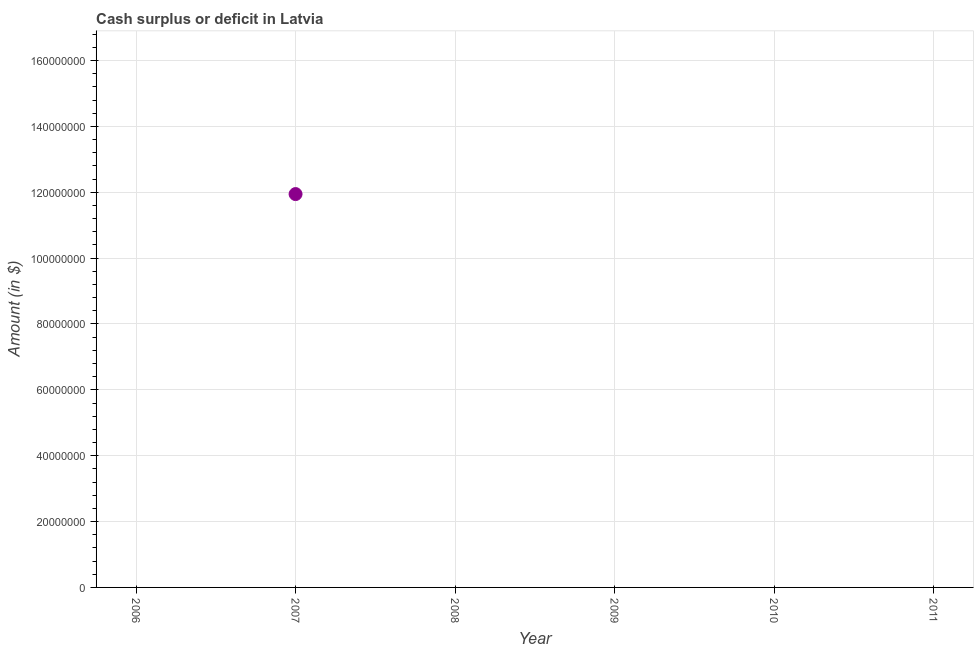What is the cash surplus or deficit in 2010?
Give a very brief answer. 0. Across all years, what is the maximum cash surplus or deficit?
Provide a succinct answer. 1.19e+08. What is the sum of the cash surplus or deficit?
Offer a terse response. 1.19e+08. What is the average cash surplus or deficit per year?
Make the answer very short. 1.99e+07. What is the median cash surplus or deficit?
Your answer should be very brief. 0. In how many years, is the cash surplus or deficit greater than 60000000 $?
Make the answer very short. 1. What is the difference between the highest and the lowest cash surplus or deficit?
Make the answer very short. 1.19e+08. In how many years, is the cash surplus or deficit greater than the average cash surplus or deficit taken over all years?
Provide a succinct answer. 1. How many dotlines are there?
Provide a succinct answer. 1. How many years are there in the graph?
Offer a very short reply. 6. Are the values on the major ticks of Y-axis written in scientific E-notation?
Keep it short and to the point. No. Does the graph contain any zero values?
Offer a very short reply. Yes. What is the title of the graph?
Make the answer very short. Cash surplus or deficit in Latvia. What is the label or title of the Y-axis?
Your answer should be very brief. Amount (in $). What is the Amount (in $) in 2006?
Give a very brief answer. 0. What is the Amount (in $) in 2007?
Your answer should be compact. 1.19e+08. What is the Amount (in $) in 2008?
Make the answer very short. 0. What is the Amount (in $) in 2009?
Offer a very short reply. 0. 